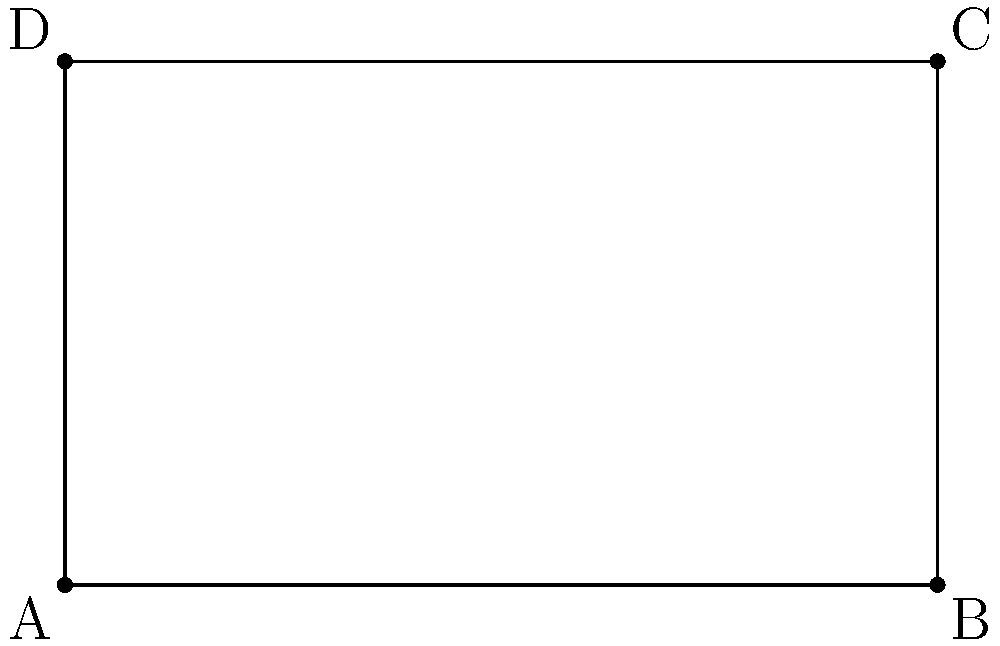Given a rectangle ABCD with vertices A(-2, -1), B(3, -1), C(3, 2), and D(-2, 2), write a Python function to calculate its area. The function should take the coordinates of the four vertices as input parameters and return the area of the rectangle. To calculate the area of a rectangle given the coordinates of its vertices, we can follow these steps:

1. Calculate the length of one side (e.g., AB):
   $$length = \sqrt{(x_B - x_A)^2 + (y_B - y_A)^2}$$

2. Calculate the length of an adjacent side (e.g., AD):
   $$width = \sqrt{(x_D - x_A)^2 + (y_D - y_A)^2}$$

3. Calculate the area by multiplying length and width:
   $$area = length * width$$

Here's a Python function that implements this logic:

```python
import math

def calculate_rectangle_area(A, B, C, D):
    length = math.sqrt((B[0] - A[0])**2 + (B[1] - A[1])**2)
    width = math.sqrt((D[0] - A[0])**2 + (D[1] - A[1])**2)
    return length * width
```

To use this function:

```python
A = (-2, -1)
B = (3, -1)
C = (3, 2)
D = (-2, 2)

area = calculate_rectangle_area(A, B, C, D)
print(f"The area of the rectangle is {area}")
```

This approach calculates the lengths of two adjacent sides and multiplies them to get the area, which is more efficient than using the shoelace formula or other methods that might be used for irregular quadrilaterals.
Answer: def calculate_rectangle_area(A, B, C, D):
    return abs((B[0] - A[0]) * (D[1] - A[1])) 